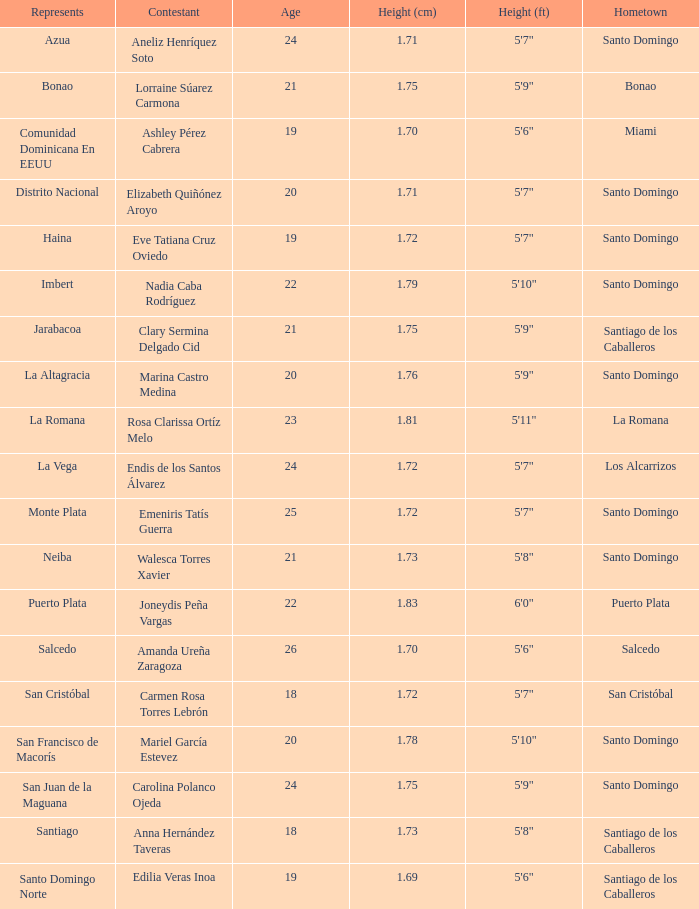How can 1.76 cm be denoted? La Altagracia. 